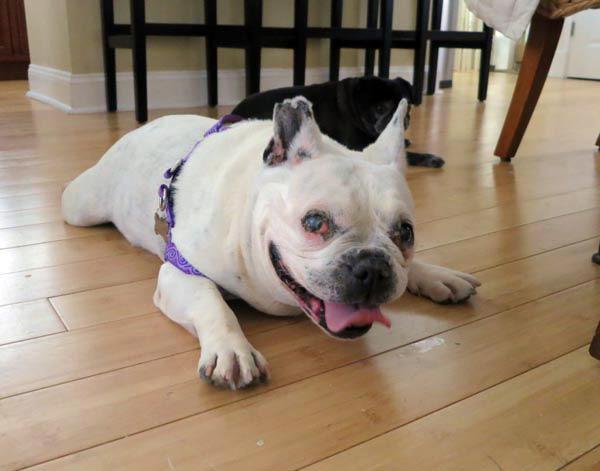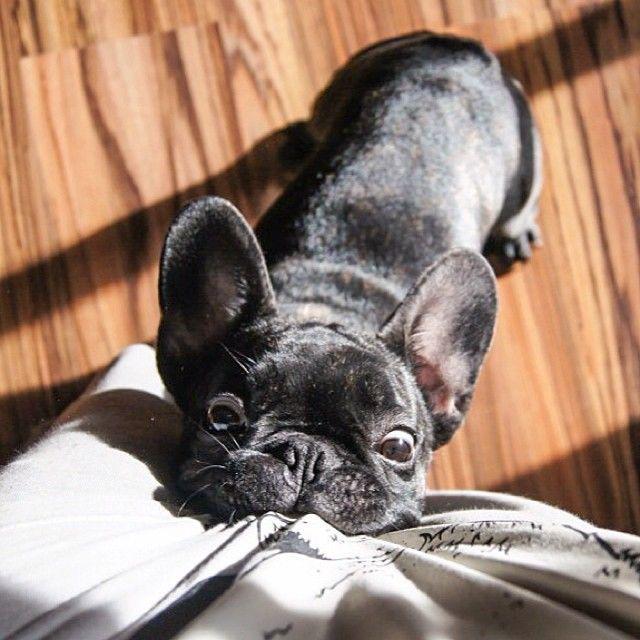The first image is the image on the left, the second image is the image on the right. Examine the images to the left and right. Is the description "The right image contains one dark french bulldog facing forward, the left image contains a white bulldog in the foreground, and one of the dogs pictured has its tongue out." accurate? Answer yes or no. Yes. 